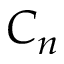<formula> <loc_0><loc_0><loc_500><loc_500>C _ { n }</formula> 